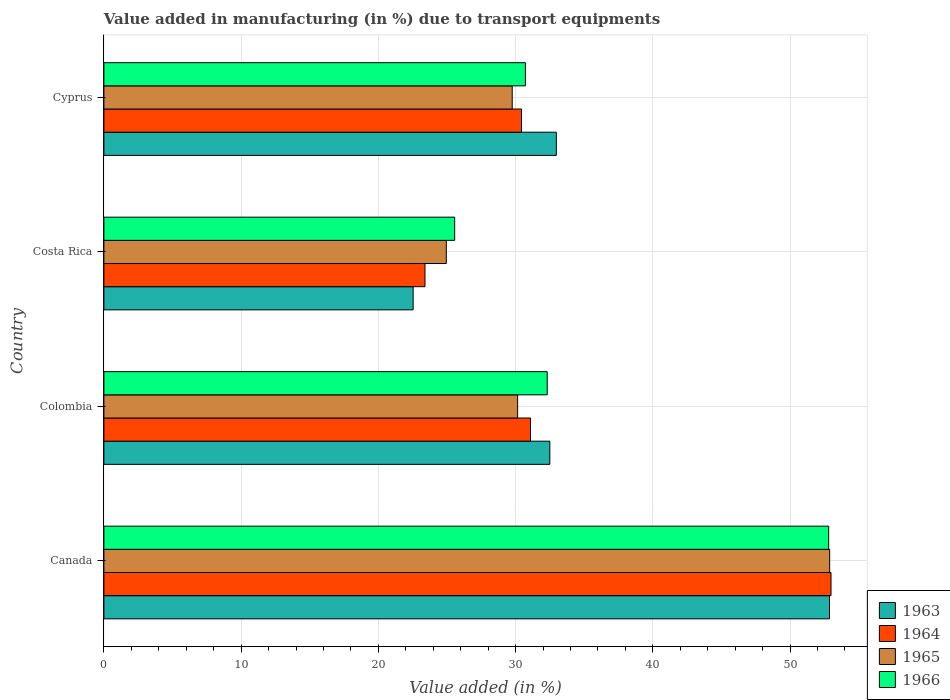How many different coloured bars are there?
Offer a very short reply. 4. How many groups of bars are there?
Keep it short and to the point. 4. How many bars are there on the 3rd tick from the top?
Offer a very short reply. 4. How many bars are there on the 3rd tick from the bottom?
Provide a succinct answer. 4. What is the percentage of value added in manufacturing due to transport equipments in 1966 in Canada?
Keep it short and to the point. 52.81. Across all countries, what is the maximum percentage of value added in manufacturing due to transport equipments in 1966?
Keep it short and to the point. 52.81. Across all countries, what is the minimum percentage of value added in manufacturing due to transport equipments in 1964?
Ensure brevity in your answer.  23.4. In which country was the percentage of value added in manufacturing due to transport equipments in 1966 maximum?
Ensure brevity in your answer.  Canada. What is the total percentage of value added in manufacturing due to transport equipments in 1966 in the graph?
Offer a terse response. 141.39. What is the difference between the percentage of value added in manufacturing due to transport equipments in 1963 in Colombia and that in Cyprus?
Your response must be concise. -0.47. What is the difference between the percentage of value added in manufacturing due to transport equipments in 1965 in Colombia and the percentage of value added in manufacturing due to transport equipments in 1966 in Cyprus?
Keep it short and to the point. -0.57. What is the average percentage of value added in manufacturing due to transport equipments in 1963 per country?
Ensure brevity in your answer.  35.22. What is the difference between the percentage of value added in manufacturing due to transport equipments in 1965 and percentage of value added in manufacturing due to transport equipments in 1964 in Canada?
Ensure brevity in your answer.  -0.1. What is the ratio of the percentage of value added in manufacturing due to transport equipments in 1965 in Canada to that in Colombia?
Provide a succinct answer. 1.75. Is the percentage of value added in manufacturing due to transport equipments in 1965 in Canada less than that in Cyprus?
Your answer should be very brief. No. Is the difference between the percentage of value added in manufacturing due to transport equipments in 1965 in Canada and Cyprus greater than the difference between the percentage of value added in manufacturing due to transport equipments in 1964 in Canada and Cyprus?
Make the answer very short. Yes. What is the difference between the highest and the second highest percentage of value added in manufacturing due to transport equipments in 1964?
Make the answer very short. 21.9. What is the difference between the highest and the lowest percentage of value added in manufacturing due to transport equipments in 1965?
Ensure brevity in your answer.  27.93. Is it the case that in every country, the sum of the percentage of value added in manufacturing due to transport equipments in 1965 and percentage of value added in manufacturing due to transport equipments in 1964 is greater than the sum of percentage of value added in manufacturing due to transport equipments in 1963 and percentage of value added in manufacturing due to transport equipments in 1966?
Provide a short and direct response. No. What does the 1st bar from the top in Cyprus represents?
Provide a short and direct response. 1966. What does the 1st bar from the bottom in Colombia represents?
Your response must be concise. 1963. Is it the case that in every country, the sum of the percentage of value added in manufacturing due to transport equipments in 1964 and percentage of value added in manufacturing due to transport equipments in 1966 is greater than the percentage of value added in manufacturing due to transport equipments in 1965?
Offer a terse response. Yes. How many bars are there?
Give a very brief answer. 16. Are all the bars in the graph horizontal?
Offer a very short reply. Yes. Are the values on the major ticks of X-axis written in scientific E-notation?
Your answer should be compact. No. Does the graph contain grids?
Ensure brevity in your answer.  Yes. How are the legend labels stacked?
Offer a very short reply. Vertical. What is the title of the graph?
Provide a succinct answer. Value added in manufacturing (in %) due to transport equipments. Does "1963" appear as one of the legend labels in the graph?
Provide a short and direct response. Yes. What is the label or title of the X-axis?
Make the answer very short. Value added (in %). What is the Value added (in %) in 1963 in Canada?
Your answer should be compact. 52.87. What is the Value added (in %) of 1964 in Canada?
Provide a short and direct response. 52.98. What is the Value added (in %) of 1965 in Canada?
Your response must be concise. 52.89. What is the Value added (in %) of 1966 in Canada?
Offer a terse response. 52.81. What is the Value added (in %) in 1963 in Colombia?
Make the answer very short. 32.49. What is the Value added (in %) of 1964 in Colombia?
Offer a very short reply. 31.09. What is the Value added (in %) of 1965 in Colombia?
Your answer should be compact. 30.15. What is the Value added (in %) in 1966 in Colombia?
Your response must be concise. 32.3. What is the Value added (in %) of 1963 in Costa Rica?
Your answer should be very brief. 22.53. What is the Value added (in %) in 1964 in Costa Rica?
Offer a terse response. 23.4. What is the Value added (in %) in 1965 in Costa Rica?
Your answer should be compact. 24.95. What is the Value added (in %) of 1966 in Costa Rica?
Keep it short and to the point. 25.56. What is the Value added (in %) of 1963 in Cyprus?
Offer a terse response. 32.97. What is the Value added (in %) in 1964 in Cyprus?
Provide a short and direct response. 30.43. What is the Value added (in %) of 1965 in Cyprus?
Offer a very short reply. 29.75. What is the Value added (in %) in 1966 in Cyprus?
Make the answer very short. 30.72. Across all countries, what is the maximum Value added (in %) in 1963?
Your answer should be compact. 52.87. Across all countries, what is the maximum Value added (in %) in 1964?
Provide a succinct answer. 52.98. Across all countries, what is the maximum Value added (in %) of 1965?
Make the answer very short. 52.89. Across all countries, what is the maximum Value added (in %) of 1966?
Give a very brief answer. 52.81. Across all countries, what is the minimum Value added (in %) in 1963?
Ensure brevity in your answer.  22.53. Across all countries, what is the minimum Value added (in %) in 1964?
Your answer should be very brief. 23.4. Across all countries, what is the minimum Value added (in %) of 1965?
Make the answer very short. 24.95. Across all countries, what is the minimum Value added (in %) of 1966?
Offer a very short reply. 25.56. What is the total Value added (in %) in 1963 in the graph?
Your answer should be compact. 140.87. What is the total Value added (in %) in 1964 in the graph?
Give a very brief answer. 137.89. What is the total Value added (in %) of 1965 in the graph?
Provide a succinct answer. 137.73. What is the total Value added (in %) of 1966 in the graph?
Provide a succinct answer. 141.39. What is the difference between the Value added (in %) in 1963 in Canada and that in Colombia?
Offer a very short reply. 20.38. What is the difference between the Value added (in %) of 1964 in Canada and that in Colombia?
Offer a terse response. 21.9. What is the difference between the Value added (in %) of 1965 in Canada and that in Colombia?
Make the answer very short. 22.74. What is the difference between the Value added (in %) in 1966 in Canada and that in Colombia?
Your answer should be compact. 20.51. What is the difference between the Value added (in %) of 1963 in Canada and that in Costa Rica?
Give a very brief answer. 30.34. What is the difference between the Value added (in %) in 1964 in Canada and that in Costa Rica?
Offer a very short reply. 29.59. What is the difference between the Value added (in %) of 1965 in Canada and that in Costa Rica?
Give a very brief answer. 27.93. What is the difference between the Value added (in %) in 1966 in Canada and that in Costa Rica?
Ensure brevity in your answer.  27.25. What is the difference between the Value added (in %) in 1963 in Canada and that in Cyprus?
Provide a short and direct response. 19.91. What is the difference between the Value added (in %) in 1964 in Canada and that in Cyprus?
Your answer should be very brief. 22.55. What is the difference between the Value added (in %) of 1965 in Canada and that in Cyprus?
Give a very brief answer. 23.13. What is the difference between the Value added (in %) in 1966 in Canada and that in Cyprus?
Make the answer very short. 22.1. What is the difference between the Value added (in %) of 1963 in Colombia and that in Costa Rica?
Provide a succinct answer. 9.96. What is the difference between the Value added (in %) in 1964 in Colombia and that in Costa Rica?
Provide a succinct answer. 7.69. What is the difference between the Value added (in %) of 1965 in Colombia and that in Costa Rica?
Offer a terse response. 5.2. What is the difference between the Value added (in %) of 1966 in Colombia and that in Costa Rica?
Offer a very short reply. 6.74. What is the difference between the Value added (in %) in 1963 in Colombia and that in Cyprus?
Give a very brief answer. -0.47. What is the difference between the Value added (in %) in 1964 in Colombia and that in Cyprus?
Your answer should be very brief. 0.66. What is the difference between the Value added (in %) of 1965 in Colombia and that in Cyprus?
Offer a very short reply. 0.39. What is the difference between the Value added (in %) in 1966 in Colombia and that in Cyprus?
Offer a terse response. 1.59. What is the difference between the Value added (in %) in 1963 in Costa Rica and that in Cyprus?
Provide a succinct answer. -10.43. What is the difference between the Value added (in %) of 1964 in Costa Rica and that in Cyprus?
Your response must be concise. -7.03. What is the difference between the Value added (in %) of 1965 in Costa Rica and that in Cyprus?
Provide a short and direct response. -4.8. What is the difference between the Value added (in %) of 1966 in Costa Rica and that in Cyprus?
Make the answer very short. -5.16. What is the difference between the Value added (in %) of 1963 in Canada and the Value added (in %) of 1964 in Colombia?
Your answer should be compact. 21.79. What is the difference between the Value added (in %) in 1963 in Canada and the Value added (in %) in 1965 in Colombia?
Offer a terse response. 22.73. What is the difference between the Value added (in %) in 1963 in Canada and the Value added (in %) in 1966 in Colombia?
Offer a very short reply. 20.57. What is the difference between the Value added (in %) in 1964 in Canada and the Value added (in %) in 1965 in Colombia?
Give a very brief answer. 22.84. What is the difference between the Value added (in %) of 1964 in Canada and the Value added (in %) of 1966 in Colombia?
Provide a succinct answer. 20.68. What is the difference between the Value added (in %) in 1965 in Canada and the Value added (in %) in 1966 in Colombia?
Your answer should be compact. 20.58. What is the difference between the Value added (in %) in 1963 in Canada and the Value added (in %) in 1964 in Costa Rica?
Provide a short and direct response. 29.48. What is the difference between the Value added (in %) in 1963 in Canada and the Value added (in %) in 1965 in Costa Rica?
Provide a succinct answer. 27.92. What is the difference between the Value added (in %) in 1963 in Canada and the Value added (in %) in 1966 in Costa Rica?
Offer a very short reply. 27.31. What is the difference between the Value added (in %) in 1964 in Canada and the Value added (in %) in 1965 in Costa Rica?
Offer a terse response. 28.03. What is the difference between the Value added (in %) in 1964 in Canada and the Value added (in %) in 1966 in Costa Rica?
Provide a short and direct response. 27.42. What is the difference between the Value added (in %) of 1965 in Canada and the Value added (in %) of 1966 in Costa Rica?
Make the answer very short. 27.33. What is the difference between the Value added (in %) of 1963 in Canada and the Value added (in %) of 1964 in Cyprus?
Your answer should be very brief. 22.44. What is the difference between the Value added (in %) in 1963 in Canada and the Value added (in %) in 1965 in Cyprus?
Provide a succinct answer. 23.12. What is the difference between the Value added (in %) in 1963 in Canada and the Value added (in %) in 1966 in Cyprus?
Keep it short and to the point. 22.16. What is the difference between the Value added (in %) in 1964 in Canada and the Value added (in %) in 1965 in Cyprus?
Your response must be concise. 23.23. What is the difference between the Value added (in %) in 1964 in Canada and the Value added (in %) in 1966 in Cyprus?
Your answer should be very brief. 22.27. What is the difference between the Value added (in %) of 1965 in Canada and the Value added (in %) of 1966 in Cyprus?
Provide a succinct answer. 22.17. What is the difference between the Value added (in %) in 1963 in Colombia and the Value added (in %) in 1964 in Costa Rica?
Provide a succinct answer. 9.1. What is the difference between the Value added (in %) of 1963 in Colombia and the Value added (in %) of 1965 in Costa Rica?
Make the answer very short. 7.54. What is the difference between the Value added (in %) in 1963 in Colombia and the Value added (in %) in 1966 in Costa Rica?
Give a very brief answer. 6.93. What is the difference between the Value added (in %) in 1964 in Colombia and the Value added (in %) in 1965 in Costa Rica?
Your answer should be compact. 6.14. What is the difference between the Value added (in %) of 1964 in Colombia and the Value added (in %) of 1966 in Costa Rica?
Your answer should be compact. 5.53. What is the difference between the Value added (in %) in 1965 in Colombia and the Value added (in %) in 1966 in Costa Rica?
Ensure brevity in your answer.  4.59. What is the difference between the Value added (in %) of 1963 in Colombia and the Value added (in %) of 1964 in Cyprus?
Offer a very short reply. 2.06. What is the difference between the Value added (in %) in 1963 in Colombia and the Value added (in %) in 1965 in Cyprus?
Your answer should be compact. 2.74. What is the difference between the Value added (in %) in 1963 in Colombia and the Value added (in %) in 1966 in Cyprus?
Offer a very short reply. 1.78. What is the difference between the Value added (in %) in 1964 in Colombia and the Value added (in %) in 1965 in Cyprus?
Give a very brief answer. 1.33. What is the difference between the Value added (in %) in 1964 in Colombia and the Value added (in %) in 1966 in Cyprus?
Your answer should be compact. 0.37. What is the difference between the Value added (in %) of 1965 in Colombia and the Value added (in %) of 1966 in Cyprus?
Keep it short and to the point. -0.57. What is the difference between the Value added (in %) in 1963 in Costa Rica and the Value added (in %) in 1964 in Cyprus?
Offer a very short reply. -7.9. What is the difference between the Value added (in %) in 1963 in Costa Rica and the Value added (in %) in 1965 in Cyprus?
Ensure brevity in your answer.  -7.22. What is the difference between the Value added (in %) of 1963 in Costa Rica and the Value added (in %) of 1966 in Cyprus?
Your answer should be very brief. -8.18. What is the difference between the Value added (in %) of 1964 in Costa Rica and the Value added (in %) of 1965 in Cyprus?
Keep it short and to the point. -6.36. What is the difference between the Value added (in %) of 1964 in Costa Rica and the Value added (in %) of 1966 in Cyprus?
Provide a succinct answer. -7.32. What is the difference between the Value added (in %) of 1965 in Costa Rica and the Value added (in %) of 1966 in Cyprus?
Keep it short and to the point. -5.77. What is the average Value added (in %) of 1963 per country?
Your response must be concise. 35.22. What is the average Value added (in %) in 1964 per country?
Offer a terse response. 34.47. What is the average Value added (in %) in 1965 per country?
Your answer should be compact. 34.43. What is the average Value added (in %) of 1966 per country?
Provide a short and direct response. 35.35. What is the difference between the Value added (in %) in 1963 and Value added (in %) in 1964 in Canada?
Keep it short and to the point. -0.11. What is the difference between the Value added (in %) in 1963 and Value added (in %) in 1965 in Canada?
Offer a very short reply. -0.01. What is the difference between the Value added (in %) of 1963 and Value added (in %) of 1966 in Canada?
Offer a very short reply. 0.06. What is the difference between the Value added (in %) of 1964 and Value added (in %) of 1965 in Canada?
Ensure brevity in your answer.  0.1. What is the difference between the Value added (in %) of 1964 and Value added (in %) of 1966 in Canada?
Make the answer very short. 0.17. What is the difference between the Value added (in %) of 1965 and Value added (in %) of 1966 in Canada?
Your response must be concise. 0.07. What is the difference between the Value added (in %) of 1963 and Value added (in %) of 1964 in Colombia?
Provide a succinct answer. 1.41. What is the difference between the Value added (in %) of 1963 and Value added (in %) of 1965 in Colombia?
Provide a succinct answer. 2.35. What is the difference between the Value added (in %) in 1963 and Value added (in %) in 1966 in Colombia?
Provide a short and direct response. 0.19. What is the difference between the Value added (in %) of 1964 and Value added (in %) of 1965 in Colombia?
Give a very brief answer. 0.94. What is the difference between the Value added (in %) of 1964 and Value added (in %) of 1966 in Colombia?
Your answer should be compact. -1.22. What is the difference between the Value added (in %) in 1965 and Value added (in %) in 1966 in Colombia?
Make the answer very short. -2.16. What is the difference between the Value added (in %) of 1963 and Value added (in %) of 1964 in Costa Rica?
Keep it short and to the point. -0.86. What is the difference between the Value added (in %) of 1963 and Value added (in %) of 1965 in Costa Rica?
Provide a succinct answer. -2.42. What is the difference between the Value added (in %) in 1963 and Value added (in %) in 1966 in Costa Rica?
Provide a short and direct response. -3.03. What is the difference between the Value added (in %) of 1964 and Value added (in %) of 1965 in Costa Rica?
Your response must be concise. -1.55. What is the difference between the Value added (in %) of 1964 and Value added (in %) of 1966 in Costa Rica?
Make the answer very short. -2.16. What is the difference between the Value added (in %) of 1965 and Value added (in %) of 1966 in Costa Rica?
Offer a very short reply. -0.61. What is the difference between the Value added (in %) in 1963 and Value added (in %) in 1964 in Cyprus?
Make the answer very short. 2.54. What is the difference between the Value added (in %) in 1963 and Value added (in %) in 1965 in Cyprus?
Your response must be concise. 3.21. What is the difference between the Value added (in %) of 1963 and Value added (in %) of 1966 in Cyprus?
Your answer should be very brief. 2.25. What is the difference between the Value added (in %) of 1964 and Value added (in %) of 1965 in Cyprus?
Offer a terse response. 0.68. What is the difference between the Value added (in %) in 1964 and Value added (in %) in 1966 in Cyprus?
Provide a succinct answer. -0.29. What is the difference between the Value added (in %) in 1965 and Value added (in %) in 1966 in Cyprus?
Ensure brevity in your answer.  -0.96. What is the ratio of the Value added (in %) of 1963 in Canada to that in Colombia?
Offer a terse response. 1.63. What is the ratio of the Value added (in %) in 1964 in Canada to that in Colombia?
Ensure brevity in your answer.  1.7. What is the ratio of the Value added (in %) in 1965 in Canada to that in Colombia?
Offer a very short reply. 1.75. What is the ratio of the Value added (in %) of 1966 in Canada to that in Colombia?
Offer a very short reply. 1.63. What is the ratio of the Value added (in %) of 1963 in Canada to that in Costa Rica?
Provide a succinct answer. 2.35. What is the ratio of the Value added (in %) of 1964 in Canada to that in Costa Rica?
Offer a terse response. 2.26. What is the ratio of the Value added (in %) in 1965 in Canada to that in Costa Rica?
Offer a terse response. 2.12. What is the ratio of the Value added (in %) in 1966 in Canada to that in Costa Rica?
Make the answer very short. 2.07. What is the ratio of the Value added (in %) of 1963 in Canada to that in Cyprus?
Your answer should be very brief. 1.6. What is the ratio of the Value added (in %) in 1964 in Canada to that in Cyprus?
Your response must be concise. 1.74. What is the ratio of the Value added (in %) of 1965 in Canada to that in Cyprus?
Provide a short and direct response. 1.78. What is the ratio of the Value added (in %) in 1966 in Canada to that in Cyprus?
Give a very brief answer. 1.72. What is the ratio of the Value added (in %) in 1963 in Colombia to that in Costa Rica?
Give a very brief answer. 1.44. What is the ratio of the Value added (in %) of 1964 in Colombia to that in Costa Rica?
Provide a succinct answer. 1.33. What is the ratio of the Value added (in %) of 1965 in Colombia to that in Costa Rica?
Ensure brevity in your answer.  1.21. What is the ratio of the Value added (in %) of 1966 in Colombia to that in Costa Rica?
Make the answer very short. 1.26. What is the ratio of the Value added (in %) in 1963 in Colombia to that in Cyprus?
Offer a very short reply. 0.99. What is the ratio of the Value added (in %) of 1964 in Colombia to that in Cyprus?
Provide a succinct answer. 1.02. What is the ratio of the Value added (in %) in 1965 in Colombia to that in Cyprus?
Give a very brief answer. 1.01. What is the ratio of the Value added (in %) in 1966 in Colombia to that in Cyprus?
Give a very brief answer. 1.05. What is the ratio of the Value added (in %) of 1963 in Costa Rica to that in Cyprus?
Offer a terse response. 0.68. What is the ratio of the Value added (in %) of 1964 in Costa Rica to that in Cyprus?
Your answer should be compact. 0.77. What is the ratio of the Value added (in %) in 1965 in Costa Rica to that in Cyprus?
Give a very brief answer. 0.84. What is the ratio of the Value added (in %) in 1966 in Costa Rica to that in Cyprus?
Keep it short and to the point. 0.83. What is the difference between the highest and the second highest Value added (in %) of 1963?
Provide a short and direct response. 19.91. What is the difference between the highest and the second highest Value added (in %) of 1964?
Provide a short and direct response. 21.9. What is the difference between the highest and the second highest Value added (in %) of 1965?
Ensure brevity in your answer.  22.74. What is the difference between the highest and the second highest Value added (in %) in 1966?
Offer a very short reply. 20.51. What is the difference between the highest and the lowest Value added (in %) of 1963?
Give a very brief answer. 30.34. What is the difference between the highest and the lowest Value added (in %) of 1964?
Offer a terse response. 29.59. What is the difference between the highest and the lowest Value added (in %) of 1965?
Your response must be concise. 27.93. What is the difference between the highest and the lowest Value added (in %) of 1966?
Offer a very short reply. 27.25. 